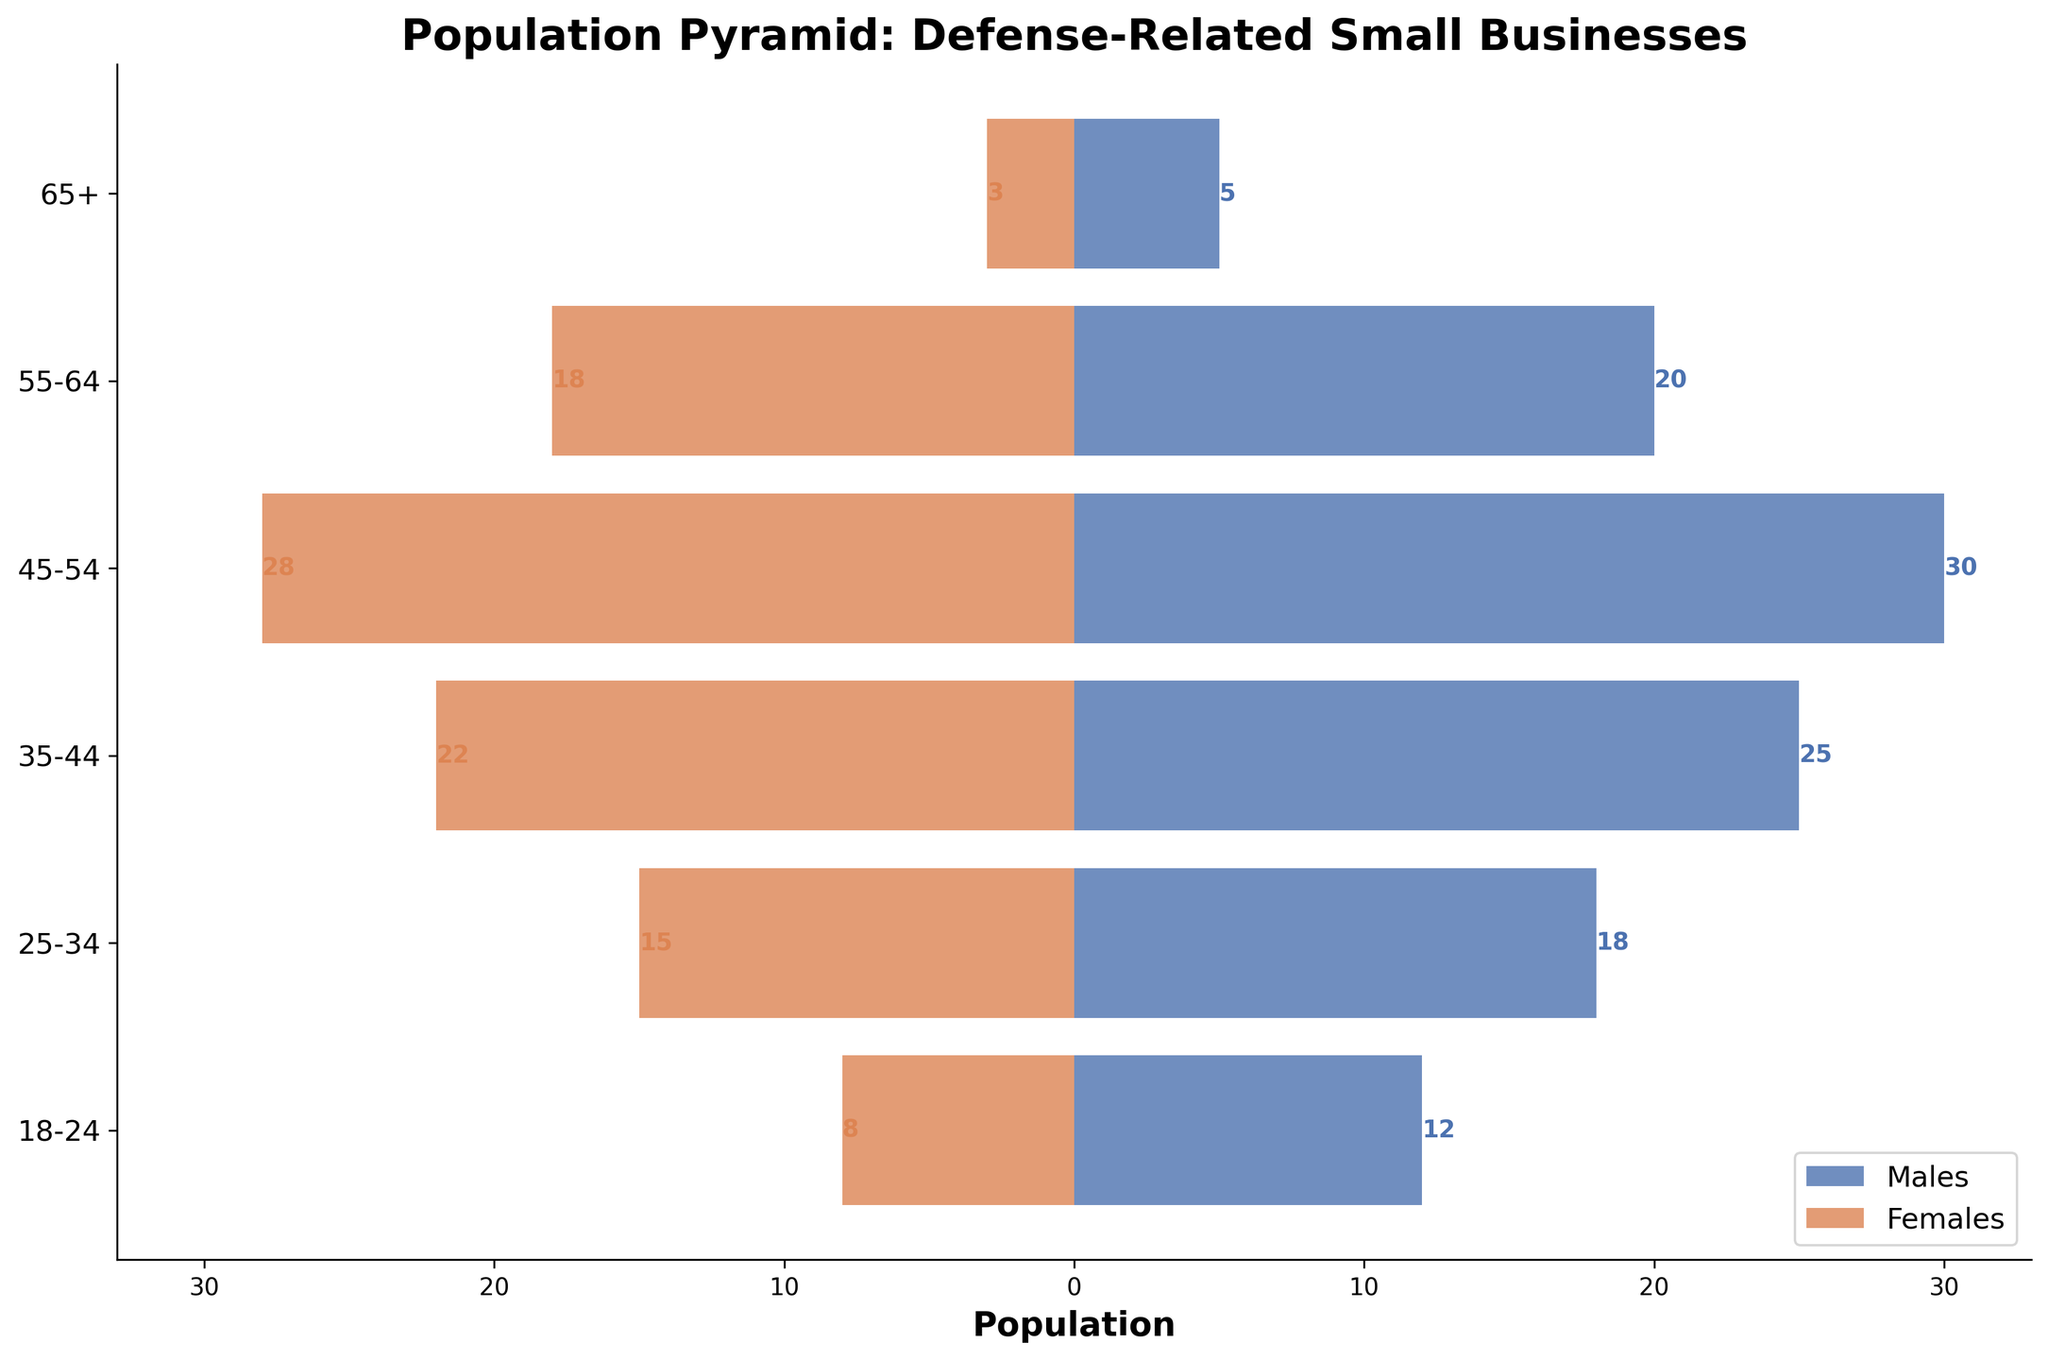What's the title of the figure? The title is usually located at the top of the figure. In this case, the title is "Population Pyramid: Defense-Related Small Businesses".
Answer: Population Pyramid: Defense-Related Small Businesses Which age group has the highest number of males? Look for the longest blue bar on the left side of the figure which represents males. The age group with the highest numbers is labeled on the Y-axis.
Answer: 45-54 Which age group has the smallest difference between males and females? Calculate the difference in population between males and females for each age group by comparing the lengths of the bars. The smallest difference will be for the age group where the lengths are closest.
Answer: 25-34 What is the range of the male population in the age group 55-64? Identify the length of the blue bar for the age group 55-64 on the left side of the figure. The male population is the numeric value alongside this bar.
Answer: 20 How many total employees (males and females combined) are in the age group 35-44? Add the number of males and females in the age group 35-44 shown by the lengths of the bars on either side.
Answer: 47 (25 males + 22 females) Which gender has more employees in the age group 18-24? Compare the lengths of the bars for males and females in the age group 18-24. The longer bar represents the gender with more employees.
Answer: Males What inference can be made about the workforce composition in the 65+ age group? Look at the lengths of the bars representing males and females in the 65+ age group. Note the overall lower values and compare them to other age groups.
Answer: Both male and female populations are significantly lower in this age group Between the age groups 45-54 and 55-64, which has a higher female population? Compare the lengths of the red bars (females) for both age groups 45-54 and 55-64. The longer bar indicates the higher female population.
Answer: 45-54 What is the total number of female employees across all age groups? Sum the values of females in all age groups: 8 (18-24) + 15 (25-34) + 22 (35-44) + 28 (45-54) + 18 (55-64) + 3 (65+).
Answer: 94 In the age group 45-54, what is the ratio of male to female employees? Divide the number of males by the number of females in the age group 45-54: 30 (males) / 28 (females). Simplify the fraction if necessary.
Answer: 15:14 or approximately 1.07:1 